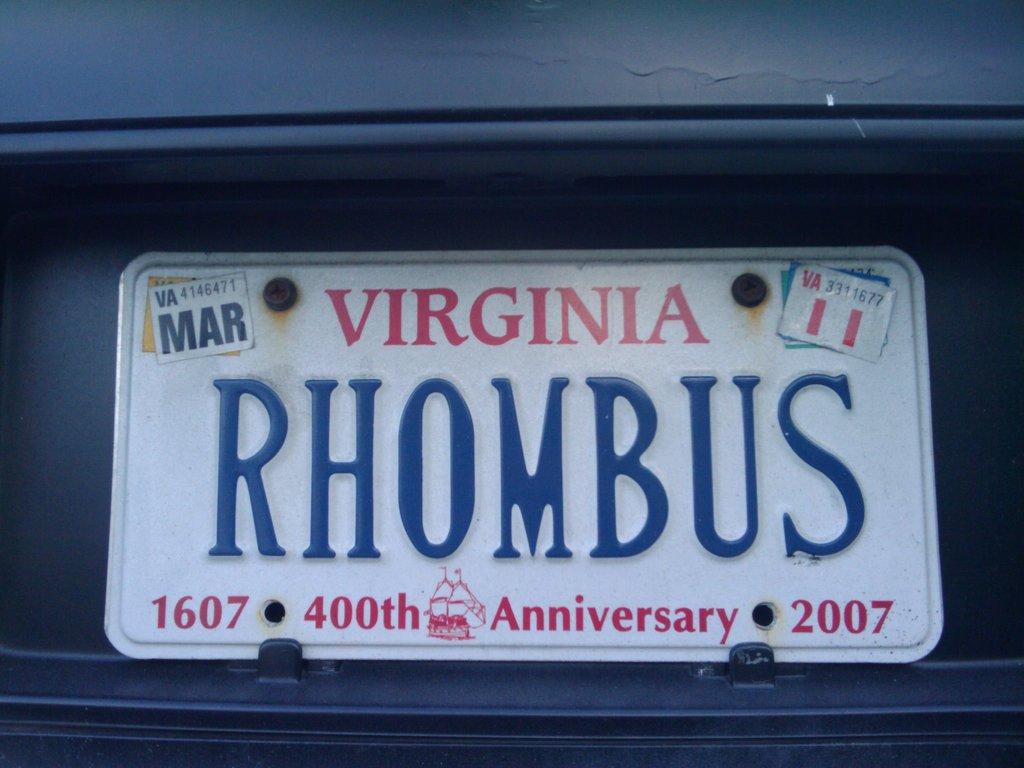What state is the license plate for?
Provide a short and direct response. Virginia. What anniversary is on the plate?
Keep it short and to the point. 400th. 